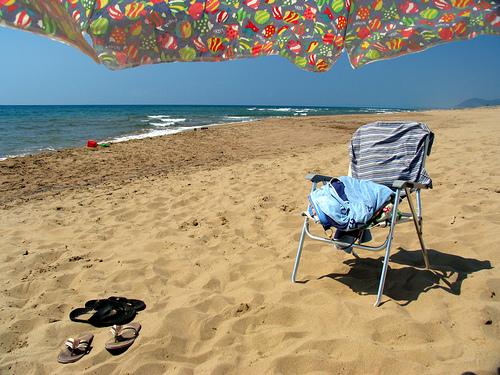What color is the chair on the sand?
Short answer required. Silver. What kind of pattern is on the umbrella?
Short answer required. Fish. Is the chair casting a shadow?
Write a very short answer. Yes. 